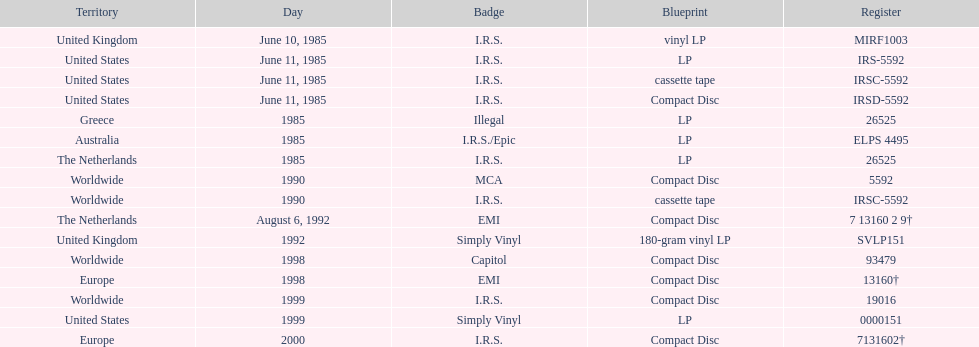How many more releases were in compact disc format than cassette tape? 5. 